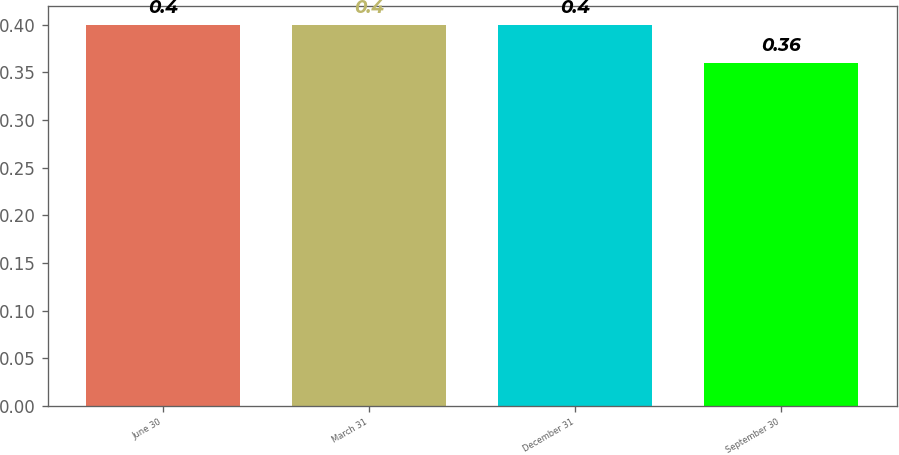Convert chart to OTSL. <chart><loc_0><loc_0><loc_500><loc_500><bar_chart><fcel>June 30<fcel>March 31<fcel>December 31<fcel>September 30<nl><fcel>0.4<fcel>0.4<fcel>0.4<fcel>0.36<nl></chart> 